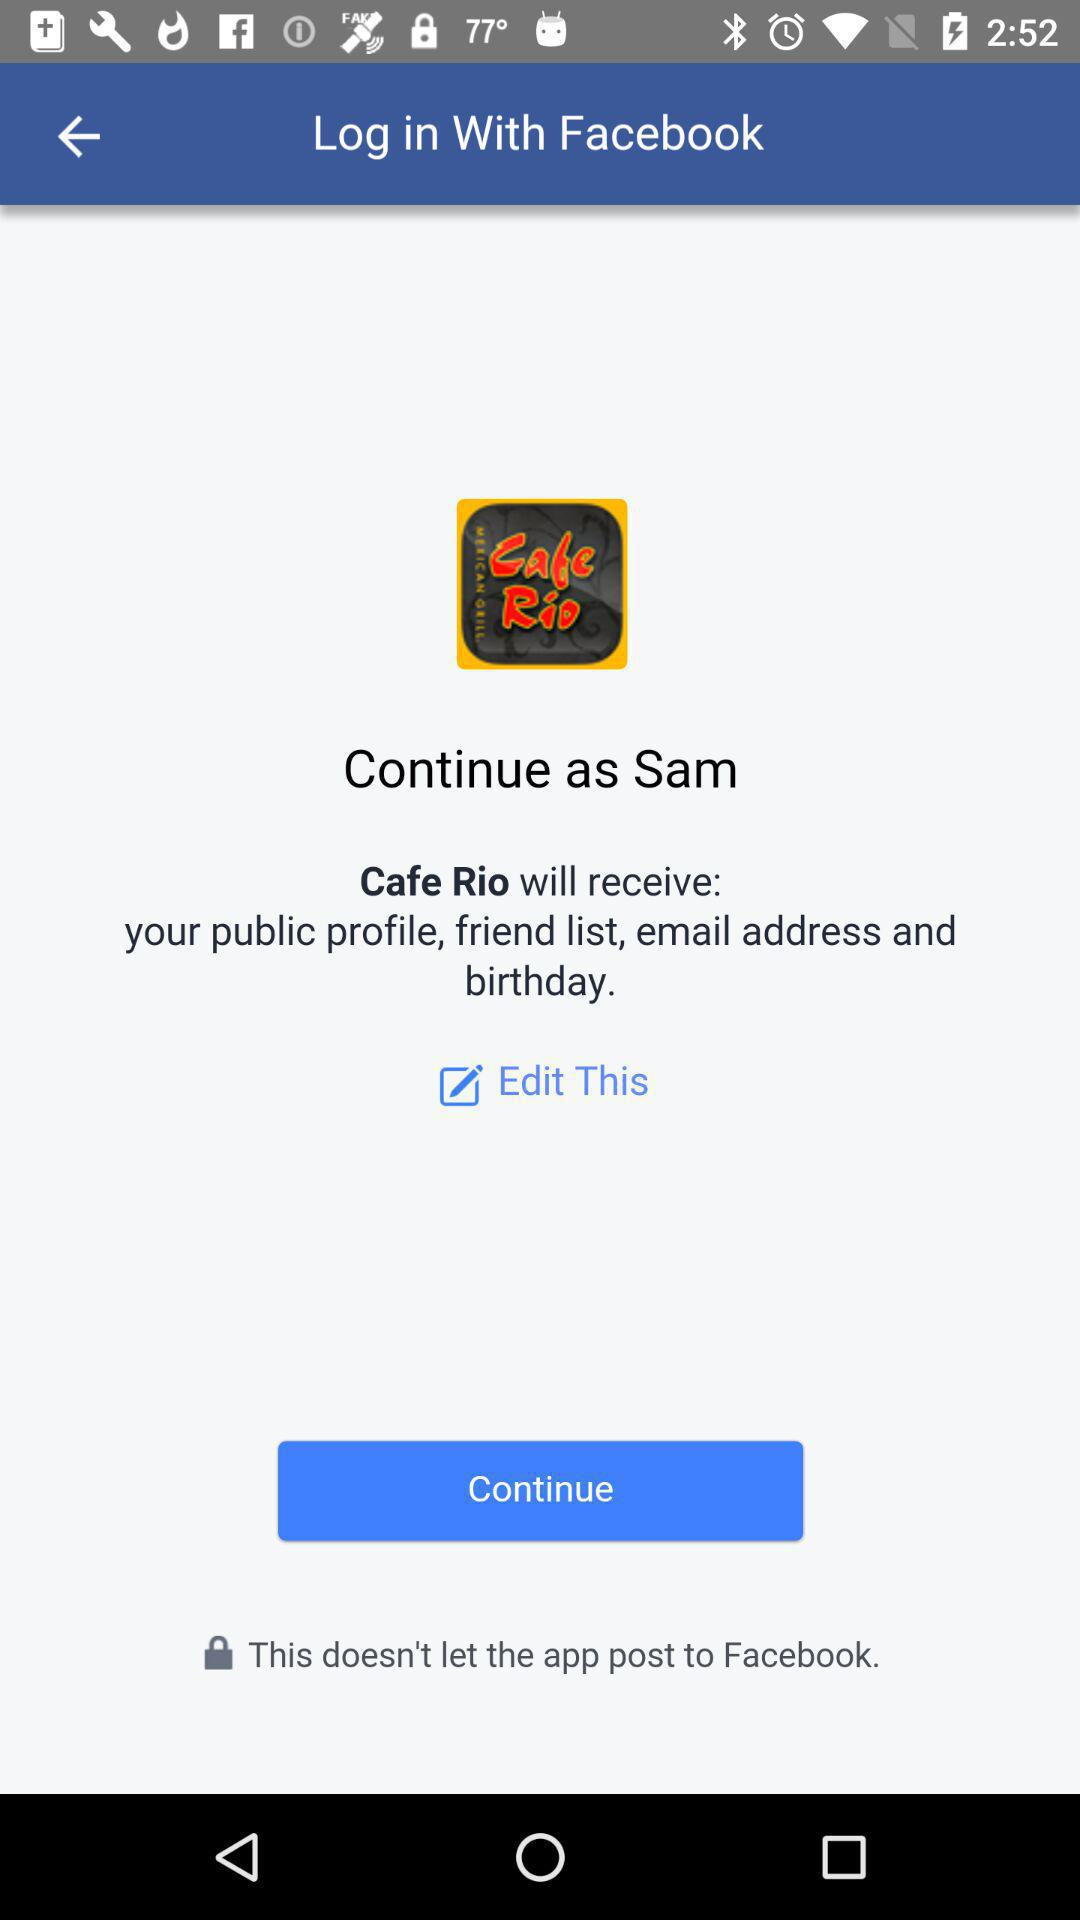What application did we use to log in? The application used to log in is "Facebook". 